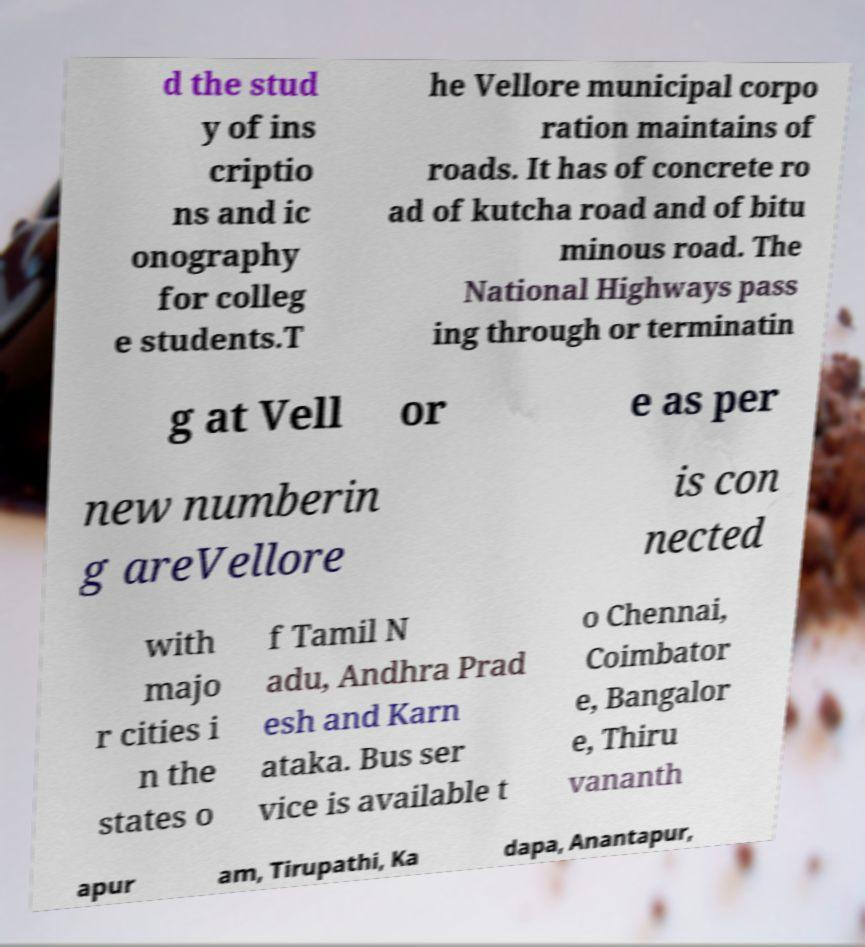For documentation purposes, I need the text within this image transcribed. Could you provide that? d the stud y of ins criptio ns and ic onography for colleg e students.T he Vellore municipal corpo ration maintains of roads. It has of concrete ro ad of kutcha road and of bitu minous road. The National Highways pass ing through or terminatin g at Vell or e as per new numberin g areVellore is con nected with majo r cities i n the states o f Tamil N adu, Andhra Prad esh and Karn ataka. Bus ser vice is available t o Chennai, Coimbator e, Bangalor e, Thiru vananth apur am, Tirupathi, Ka dapa, Anantapur, 